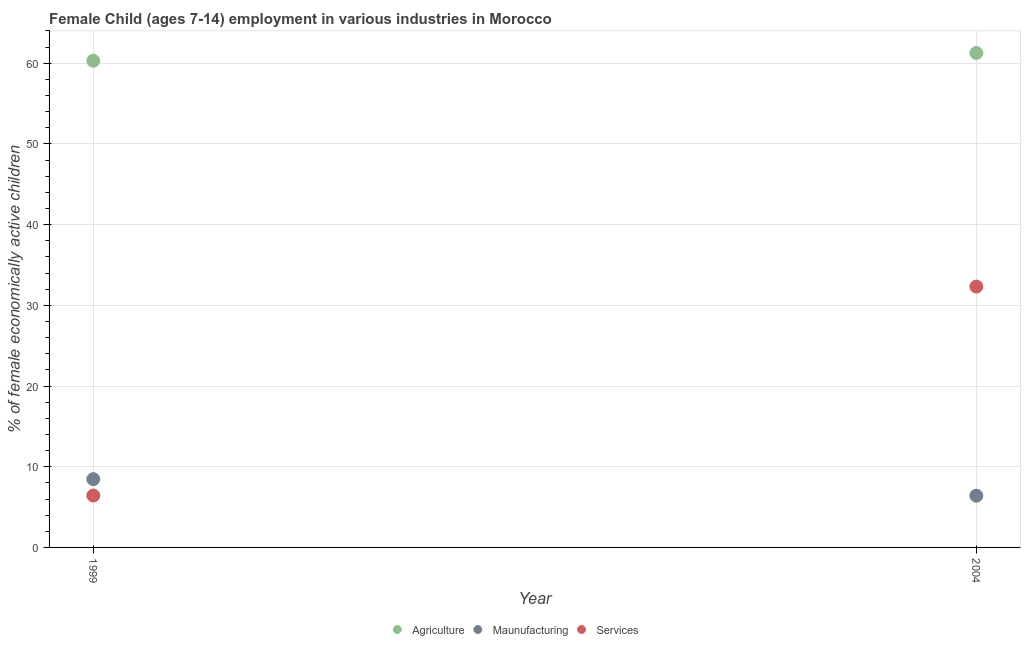How many different coloured dotlines are there?
Your response must be concise. 3. What is the percentage of economically active children in manufacturing in 2004?
Offer a very short reply. 6.41. Across all years, what is the maximum percentage of economically active children in manufacturing?
Ensure brevity in your answer.  8.46. Across all years, what is the minimum percentage of economically active children in manufacturing?
Offer a very short reply. 6.41. In which year was the percentage of economically active children in manufacturing maximum?
Keep it short and to the point. 1999. In which year was the percentage of economically active children in agriculture minimum?
Your answer should be compact. 1999. What is the total percentage of economically active children in manufacturing in the graph?
Your answer should be compact. 14.87. What is the difference between the percentage of economically active children in agriculture in 1999 and that in 2004?
Keep it short and to the point. -0.97. What is the difference between the percentage of economically active children in agriculture in 1999 and the percentage of economically active children in services in 2004?
Your answer should be compact. 27.98. What is the average percentage of economically active children in services per year?
Offer a terse response. 19.38. In the year 2004, what is the difference between the percentage of economically active children in agriculture and percentage of economically active children in services?
Make the answer very short. 28.95. What is the ratio of the percentage of economically active children in services in 1999 to that in 2004?
Provide a succinct answer. 0.2. Is the percentage of economically active children in services in 1999 less than that in 2004?
Provide a short and direct response. Yes. Is it the case that in every year, the sum of the percentage of economically active children in agriculture and percentage of economically active children in manufacturing is greater than the percentage of economically active children in services?
Provide a short and direct response. Yes. How many dotlines are there?
Your answer should be compact. 3. What is the difference between two consecutive major ticks on the Y-axis?
Offer a terse response. 10. Does the graph contain any zero values?
Provide a succinct answer. No. How many legend labels are there?
Provide a succinct answer. 3. How are the legend labels stacked?
Make the answer very short. Horizontal. What is the title of the graph?
Ensure brevity in your answer.  Female Child (ages 7-14) employment in various industries in Morocco. What is the label or title of the X-axis?
Your response must be concise. Year. What is the label or title of the Y-axis?
Provide a succinct answer. % of female economically active children. What is the % of female economically active children in Agriculture in 1999?
Keep it short and to the point. 60.3. What is the % of female economically active children of Maunufacturing in 1999?
Your answer should be very brief. 8.46. What is the % of female economically active children of Services in 1999?
Ensure brevity in your answer.  6.43. What is the % of female economically active children of Agriculture in 2004?
Give a very brief answer. 61.27. What is the % of female economically active children of Maunufacturing in 2004?
Give a very brief answer. 6.41. What is the % of female economically active children in Services in 2004?
Your answer should be compact. 32.32. Across all years, what is the maximum % of female economically active children of Agriculture?
Your answer should be very brief. 61.27. Across all years, what is the maximum % of female economically active children in Maunufacturing?
Make the answer very short. 8.46. Across all years, what is the maximum % of female economically active children of Services?
Offer a very short reply. 32.32. Across all years, what is the minimum % of female economically active children in Agriculture?
Your answer should be compact. 60.3. Across all years, what is the minimum % of female economically active children of Maunufacturing?
Your answer should be compact. 6.41. Across all years, what is the minimum % of female economically active children in Services?
Provide a short and direct response. 6.43. What is the total % of female economically active children in Agriculture in the graph?
Give a very brief answer. 121.57. What is the total % of female economically active children of Maunufacturing in the graph?
Ensure brevity in your answer.  14.87. What is the total % of female economically active children in Services in the graph?
Make the answer very short. 38.75. What is the difference between the % of female economically active children in Agriculture in 1999 and that in 2004?
Give a very brief answer. -0.97. What is the difference between the % of female economically active children of Maunufacturing in 1999 and that in 2004?
Your response must be concise. 2.05. What is the difference between the % of female economically active children of Services in 1999 and that in 2004?
Your answer should be compact. -25.89. What is the difference between the % of female economically active children in Agriculture in 1999 and the % of female economically active children in Maunufacturing in 2004?
Provide a succinct answer. 53.89. What is the difference between the % of female economically active children of Agriculture in 1999 and the % of female economically active children of Services in 2004?
Your response must be concise. 27.98. What is the difference between the % of female economically active children in Maunufacturing in 1999 and the % of female economically active children in Services in 2004?
Make the answer very short. -23.86. What is the average % of female economically active children of Agriculture per year?
Keep it short and to the point. 60.78. What is the average % of female economically active children of Maunufacturing per year?
Ensure brevity in your answer.  7.43. What is the average % of female economically active children of Services per year?
Ensure brevity in your answer.  19.38. In the year 1999, what is the difference between the % of female economically active children of Agriculture and % of female economically active children of Maunufacturing?
Give a very brief answer. 51.84. In the year 1999, what is the difference between the % of female economically active children of Agriculture and % of female economically active children of Services?
Offer a terse response. 53.87. In the year 1999, what is the difference between the % of female economically active children of Maunufacturing and % of female economically active children of Services?
Your answer should be very brief. 2.03. In the year 2004, what is the difference between the % of female economically active children of Agriculture and % of female economically active children of Maunufacturing?
Your answer should be compact. 54.86. In the year 2004, what is the difference between the % of female economically active children in Agriculture and % of female economically active children in Services?
Ensure brevity in your answer.  28.95. In the year 2004, what is the difference between the % of female economically active children in Maunufacturing and % of female economically active children in Services?
Make the answer very short. -25.91. What is the ratio of the % of female economically active children in Agriculture in 1999 to that in 2004?
Your response must be concise. 0.98. What is the ratio of the % of female economically active children in Maunufacturing in 1999 to that in 2004?
Provide a succinct answer. 1.32. What is the ratio of the % of female economically active children of Services in 1999 to that in 2004?
Offer a very short reply. 0.2. What is the difference between the highest and the second highest % of female economically active children in Agriculture?
Offer a terse response. 0.97. What is the difference between the highest and the second highest % of female economically active children in Maunufacturing?
Offer a very short reply. 2.05. What is the difference between the highest and the second highest % of female economically active children in Services?
Your answer should be compact. 25.89. What is the difference between the highest and the lowest % of female economically active children in Agriculture?
Your answer should be very brief. 0.97. What is the difference between the highest and the lowest % of female economically active children of Maunufacturing?
Your response must be concise. 2.05. What is the difference between the highest and the lowest % of female economically active children in Services?
Give a very brief answer. 25.89. 